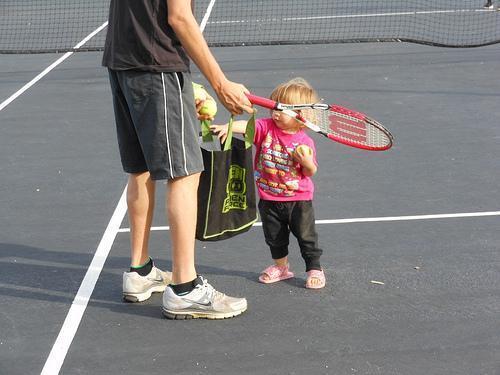How many people are there?
Give a very brief answer. 2. 